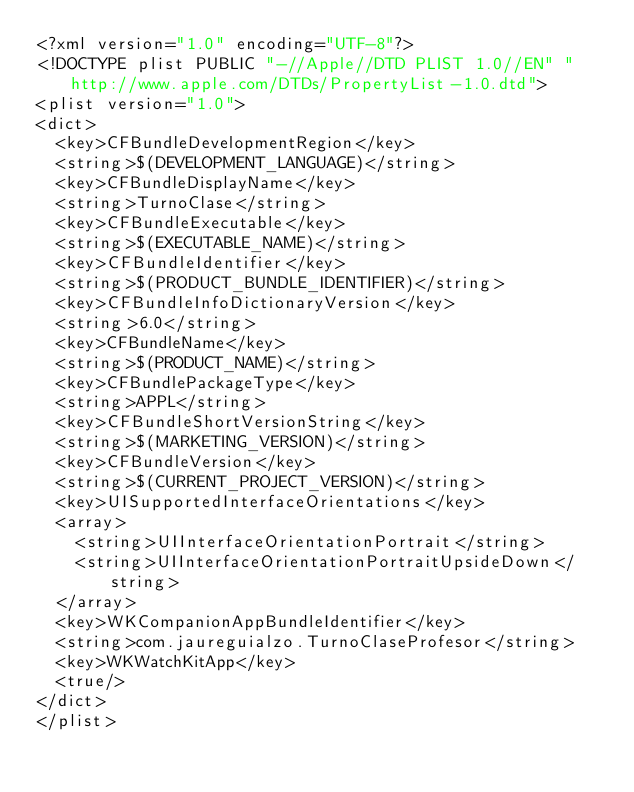Convert code to text. <code><loc_0><loc_0><loc_500><loc_500><_XML_><?xml version="1.0" encoding="UTF-8"?>
<!DOCTYPE plist PUBLIC "-//Apple//DTD PLIST 1.0//EN" "http://www.apple.com/DTDs/PropertyList-1.0.dtd">
<plist version="1.0">
<dict>
	<key>CFBundleDevelopmentRegion</key>
	<string>$(DEVELOPMENT_LANGUAGE)</string>
	<key>CFBundleDisplayName</key>
	<string>TurnoClase</string>
	<key>CFBundleExecutable</key>
	<string>$(EXECUTABLE_NAME)</string>
	<key>CFBundleIdentifier</key>
	<string>$(PRODUCT_BUNDLE_IDENTIFIER)</string>
	<key>CFBundleInfoDictionaryVersion</key>
	<string>6.0</string>
	<key>CFBundleName</key>
	<string>$(PRODUCT_NAME)</string>
	<key>CFBundlePackageType</key>
	<string>APPL</string>
	<key>CFBundleShortVersionString</key>
	<string>$(MARKETING_VERSION)</string>
	<key>CFBundleVersion</key>
	<string>$(CURRENT_PROJECT_VERSION)</string>
	<key>UISupportedInterfaceOrientations</key>
	<array>
		<string>UIInterfaceOrientationPortrait</string>
		<string>UIInterfaceOrientationPortraitUpsideDown</string>
	</array>
	<key>WKCompanionAppBundleIdentifier</key>
	<string>com.jaureguialzo.TurnoClaseProfesor</string>
	<key>WKWatchKitApp</key>
	<true/>
</dict>
</plist>
</code> 